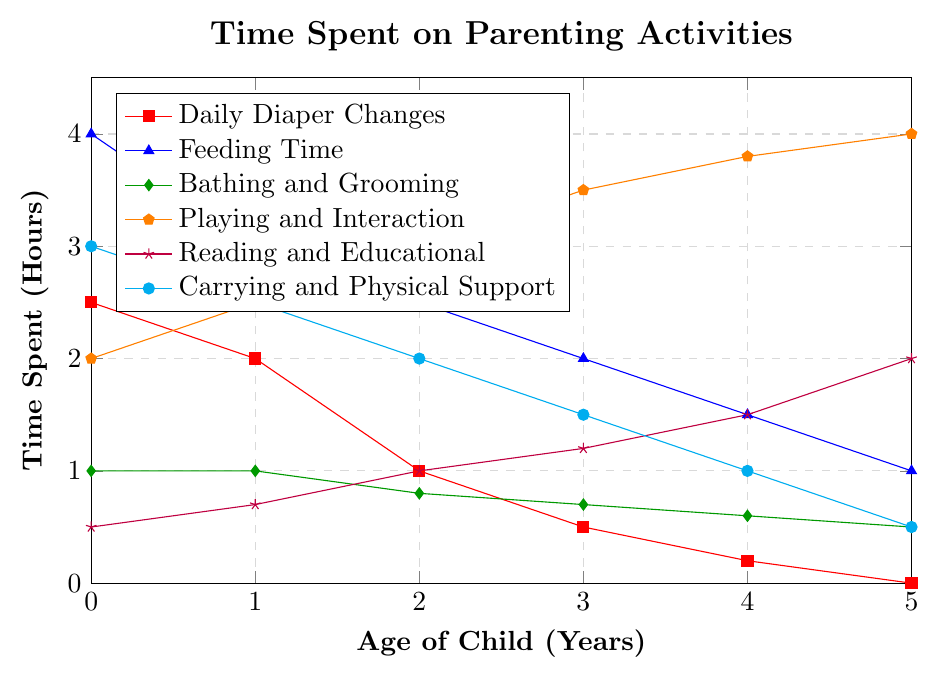What is the total time spent on "Daily Diaper Changes" over the first 3 years? Sum the values for "Daily Diaper Changes" from ages 0 to 3: 2.5 (at age 0) + 2.0 (at age 1) + 1.0 (at age 2) + 0.5 (at age 3) = 6.0 hours
Answer: 6.0 hours Which activity shows the greatest increase in time spent from age 0 to age 5? Compare the differences between the time spent at age 5 and age 0 for all activities: Daily Diaper Changes (-2.5), Feeding Time (-3.0), Bathing and Grooming (-0.5), Playing and Interaction (+2.0), Reading and Educational Activities (+1.5), Carrying and Physical Support (-2.5). Playing and Interaction has the greatest increase
Answer: Playing and Interaction How does the time spent on "Feeding Time" change as the child ages from 0 to 5? Observe the trend: The time decreases steadily over the years from 4.0 hours at age 0 to 1.0 hour at age 5
Answer: Decreases steadily Which activity has the least total time spent over the 6 years? Sum the time spent for each activity over the 6 years and compare: Daily Diaper Changes (6.2), Feeding Time (14.0), Bathing and Grooming (4.6), Playing and Interaction (18.8), Reading and Educational Activities (6.9), Carrying and Physical Support (10.5). Bathing and Grooming has the least total time
Answer: Bathing and Grooming At what age does the time spent on "Reading and Educational Activities" surpass 1 hour a day? Check the values for "Reading and Educational Activities" across ages: at age 0 (0.5), 1 (0.7), 2 (1.0), 3 (1.2) - it surpasses 1 hour at age 3
Answer: Age 3 What is the overall trend of time spent on "Carrying and Physical Support"? Examine the trend line: It starts at 3.0 hours at age 0 and decreases steadily to 0.5 hour at age 5
Answer: Decreasing steadily Which age shows the highest total time spent across all activities? Sum the time across all activities for each age and compare: Age 0 (13 hours), Age 1 (11.7 hours), Age 2 (10.3 hours), Age 3 (9.4 hours), Age 4 (8.6 hours), Age 5 (9.0 hours). Age 0 has the highest total time
Answer: Age 0 What is the difference in time spent on "Playing and Interaction" between ages 2 and 5? Subtract the time spent at age 2 from the time spent at age 5: 4.0 (at age 5) - 3.0 (at age 2) = 1.0 hour
Answer: 1.0 hour 